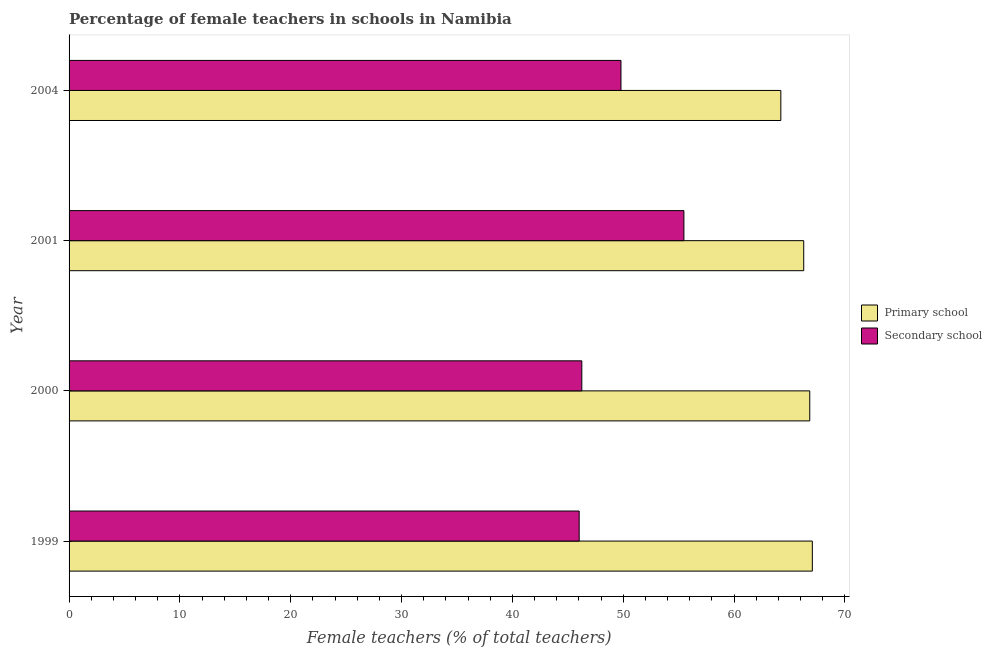How many different coloured bars are there?
Your answer should be compact. 2. How many groups of bars are there?
Ensure brevity in your answer.  4. Are the number of bars on each tick of the Y-axis equal?
Offer a terse response. Yes. How many bars are there on the 1st tick from the top?
Offer a terse response. 2. What is the percentage of female teachers in primary schools in 2004?
Your response must be concise. 64.22. Across all years, what is the maximum percentage of female teachers in secondary schools?
Provide a short and direct response. 55.47. Across all years, what is the minimum percentage of female teachers in primary schools?
Keep it short and to the point. 64.22. What is the total percentage of female teachers in secondary schools in the graph?
Provide a succinct answer. 197.56. What is the difference between the percentage of female teachers in primary schools in 1999 and that in 2001?
Provide a succinct answer. 0.78. What is the difference between the percentage of female teachers in secondary schools in 2000 and the percentage of female teachers in primary schools in 1999?
Provide a succinct answer. -20.8. What is the average percentage of female teachers in primary schools per year?
Provide a succinct answer. 66.1. In the year 2001, what is the difference between the percentage of female teachers in primary schools and percentage of female teachers in secondary schools?
Your answer should be very brief. 10.81. In how many years, is the percentage of female teachers in primary schools greater than 16 %?
Offer a terse response. 4. What is the ratio of the percentage of female teachers in secondary schools in 1999 to that in 2001?
Give a very brief answer. 0.83. What is the difference between the highest and the second highest percentage of female teachers in primary schools?
Your answer should be compact. 0.23. What is the difference between the highest and the lowest percentage of female teachers in secondary schools?
Your response must be concise. 9.45. What does the 1st bar from the top in 2000 represents?
Keep it short and to the point. Secondary school. What does the 1st bar from the bottom in 2004 represents?
Your answer should be very brief. Primary school. How many bars are there?
Keep it short and to the point. 8. How many years are there in the graph?
Your answer should be very brief. 4. Are the values on the major ticks of X-axis written in scientific E-notation?
Your response must be concise. No. Does the graph contain grids?
Make the answer very short. No. How many legend labels are there?
Provide a succinct answer. 2. What is the title of the graph?
Provide a succinct answer. Percentage of female teachers in schools in Namibia. What is the label or title of the X-axis?
Provide a short and direct response. Female teachers (% of total teachers). What is the label or title of the Y-axis?
Your answer should be compact. Year. What is the Female teachers (% of total teachers) in Primary school in 1999?
Keep it short and to the point. 67.06. What is the Female teachers (% of total teachers) of Secondary school in 1999?
Your answer should be very brief. 46.03. What is the Female teachers (% of total teachers) in Primary school in 2000?
Give a very brief answer. 66.83. What is the Female teachers (% of total teachers) of Secondary school in 2000?
Give a very brief answer. 46.26. What is the Female teachers (% of total teachers) of Primary school in 2001?
Give a very brief answer. 66.29. What is the Female teachers (% of total teachers) of Secondary school in 2001?
Your answer should be compact. 55.47. What is the Female teachers (% of total teachers) in Primary school in 2004?
Give a very brief answer. 64.22. What is the Female teachers (% of total teachers) of Secondary school in 2004?
Make the answer very short. 49.8. Across all years, what is the maximum Female teachers (% of total teachers) in Primary school?
Make the answer very short. 67.06. Across all years, what is the maximum Female teachers (% of total teachers) in Secondary school?
Keep it short and to the point. 55.47. Across all years, what is the minimum Female teachers (% of total teachers) in Primary school?
Offer a very short reply. 64.22. Across all years, what is the minimum Female teachers (% of total teachers) of Secondary school?
Give a very brief answer. 46.03. What is the total Female teachers (% of total teachers) in Primary school in the graph?
Keep it short and to the point. 264.4. What is the total Female teachers (% of total teachers) in Secondary school in the graph?
Make the answer very short. 197.56. What is the difference between the Female teachers (% of total teachers) of Primary school in 1999 and that in 2000?
Keep it short and to the point. 0.23. What is the difference between the Female teachers (% of total teachers) of Secondary school in 1999 and that in 2000?
Provide a succinct answer. -0.24. What is the difference between the Female teachers (% of total teachers) in Primary school in 1999 and that in 2001?
Keep it short and to the point. 0.78. What is the difference between the Female teachers (% of total teachers) in Secondary school in 1999 and that in 2001?
Offer a very short reply. -9.45. What is the difference between the Female teachers (% of total teachers) of Primary school in 1999 and that in 2004?
Your answer should be very brief. 2.84. What is the difference between the Female teachers (% of total teachers) in Secondary school in 1999 and that in 2004?
Keep it short and to the point. -3.77. What is the difference between the Female teachers (% of total teachers) of Primary school in 2000 and that in 2001?
Offer a terse response. 0.54. What is the difference between the Female teachers (% of total teachers) in Secondary school in 2000 and that in 2001?
Keep it short and to the point. -9.21. What is the difference between the Female teachers (% of total teachers) in Primary school in 2000 and that in 2004?
Your answer should be very brief. 2.61. What is the difference between the Female teachers (% of total teachers) in Secondary school in 2000 and that in 2004?
Ensure brevity in your answer.  -3.53. What is the difference between the Female teachers (% of total teachers) of Primary school in 2001 and that in 2004?
Offer a very short reply. 2.07. What is the difference between the Female teachers (% of total teachers) in Secondary school in 2001 and that in 2004?
Offer a very short reply. 5.68. What is the difference between the Female teachers (% of total teachers) in Primary school in 1999 and the Female teachers (% of total teachers) in Secondary school in 2000?
Your response must be concise. 20.8. What is the difference between the Female teachers (% of total teachers) in Primary school in 1999 and the Female teachers (% of total teachers) in Secondary school in 2001?
Your answer should be very brief. 11.59. What is the difference between the Female teachers (% of total teachers) of Primary school in 1999 and the Female teachers (% of total teachers) of Secondary school in 2004?
Provide a succinct answer. 17.27. What is the difference between the Female teachers (% of total teachers) in Primary school in 2000 and the Female teachers (% of total teachers) in Secondary school in 2001?
Your response must be concise. 11.35. What is the difference between the Female teachers (% of total teachers) in Primary school in 2000 and the Female teachers (% of total teachers) in Secondary school in 2004?
Make the answer very short. 17.03. What is the difference between the Female teachers (% of total teachers) of Primary school in 2001 and the Female teachers (% of total teachers) of Secondary school in 2004?
Provide a short and direct response. 16.49. What is the average Female teachers (% of total teachers) of Primary school per year?
Make the answer very short. 66.1. What is the average Female teachers (% of total teachers) in Secondary school per year?
Ensure brevity in your answer.  49.39. In the year 1999, what is the difference between the Female teachers (% of total teachers) in Primary school and Female teachers (% of total teachers) in Secondary school?
Provide a short and direct response. 21.04. In the year 2000, what is the difference between the Female teachers (% of total teachers) of Primary school and Female teachers (% of total teachers) of Secondary school?
Your answer should be very brief. 20.57. In the year 2001, what is the difference between the Female teachers (% of total teachers) in Primary school and Female teachers (% of total teachers) in Secondary school?
Give a very brief answer. 10.81. In the year 2004, what is the difference between the Female teachers (% of total teachers) in Primary school and Female teachers (% of total teachers) in Secondary school?
Give a very brief answer. 14.42. What is the ratio of the Female teachers (% of total teachers) in Secondary school in 1999 to that in 2000?
Give a very brief answer. 0.99. What is the ratio of the Female teachers (% of total teachers) of Primary school in 1999 to that in 2001?
Provide a succinct answer. 1.01. What is the ratio of the Female teachers (% of total teachers) of Secondary school in 1999 to that in 2001?
Provide a succinct answer. 0.83. What is the ratio of the Female teachers (% of total teachers) in Primary school in 1999 to that in 2004?
Offer a terse response. 1.04. What is the ratio of the Female teachers (% of total teachers) in Secondary school in 1999 to that in 2004?
Give a very brief answer. 0.92. What is the ratio of the Female teachers (% of total teachers) of Primary school in 2000 to that in 2001?
Make the answer very short. 1.01. What is the ratio of the Female teachers (% of total teachers) of Secondary school in 2000 to that in 2001?
Offer a terse response. 0.83. What is the ratio of the Female teachers (% of total teachers) in Primary school in 2000 to that in 2004?
Offer a very short reply. 1.04. What is the ratio of the Female teachers (% of total teachers) of Secondary school in 2000 to that in 2004?
Your response must be concise. 0.93. What is the ratio of the Female teachers (% of total teachers) in Primary school in 2001 to that in 2004?
Provide a succinct answer. 1.03. What is the ratio of the Female teachers (% of total teachers) in Secondary school in 2001 to that in 2004?
Your answer should be compact. 1.11. What is the difference between the highest and the second highest Female teachers (% of total teachers) in Primary school?
Your answer should be very brief. 0.23. What is the difference between the highest and the second highest Female teachers (% of total teachers) in Secondary school?
Your answer should be very brief. 5.68. What is the difference between the highest and the lowest Female teachers (% of total teachers) in Primary school?
Give a very brief answer. 2.84. What is the difference between the highest and the lowest Female teachers (% of total teachers) in Secondary school?
Your response must be concise. 9.45. 